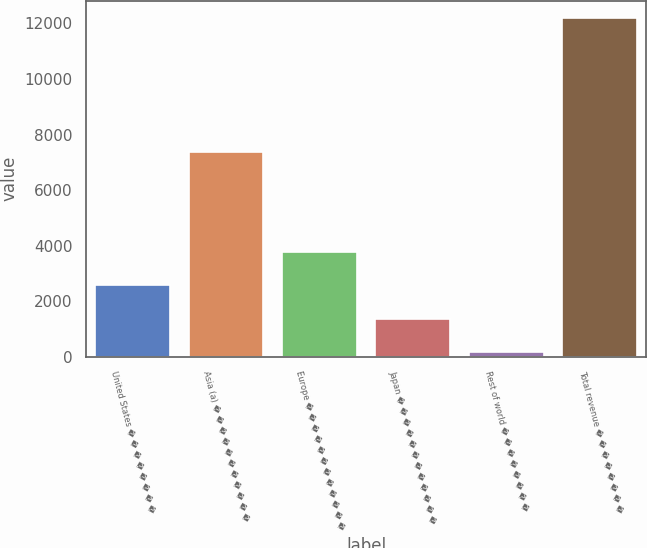<chart> <loc_0><loc_0><loc_500><loc_500><bar_chart><fcel>United States � � � � � � � �<fcel>Asia (a) � � � � � � � � � � �<fcel>Europe � � � � � � � � � � � �<fcel>Japan � � � � � � � � � � � �<fcel>Rest of world � � � � � � � �<fcel>Total revenue � � � � � � � �<nl><fcel>2577.8<fcel>7370<fcel>3781.2<fcel>1374.4<fcel>171<fcel>12205<nl></chart> 